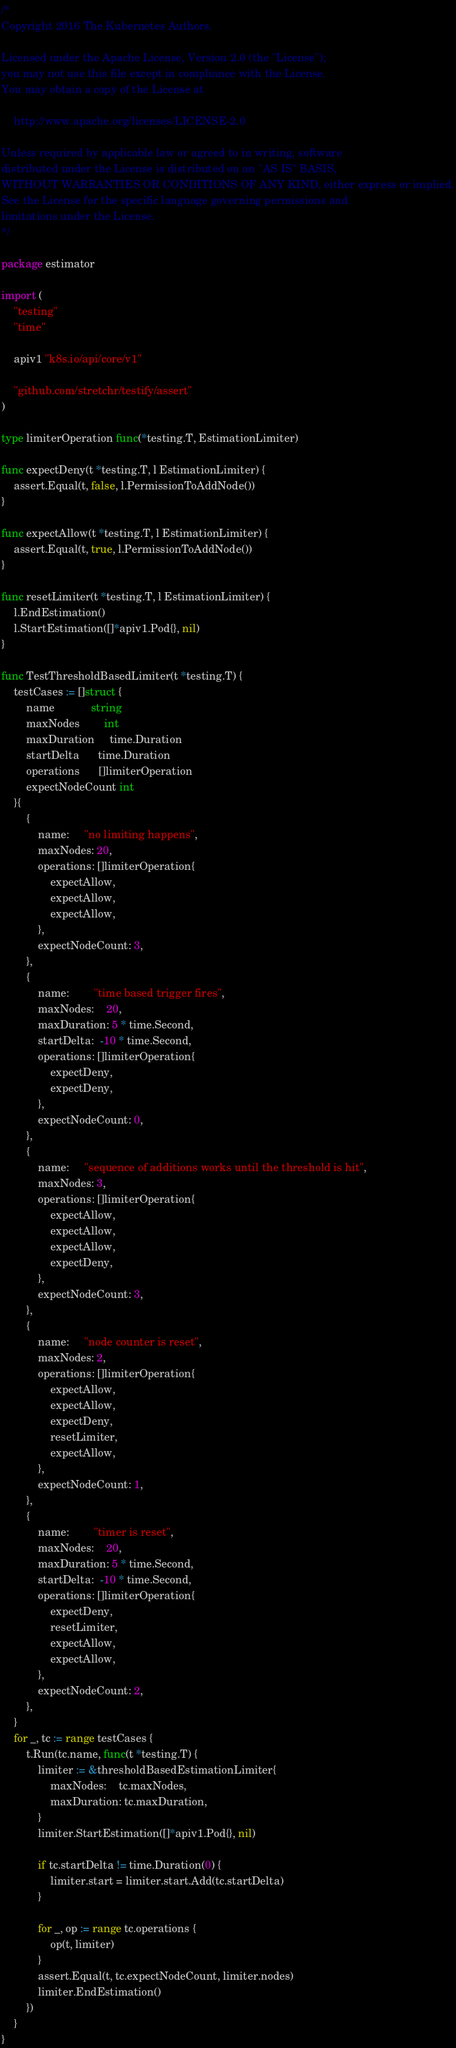<code> <loc_0><loc_0><loc_500><loc_500><_Go_>/*
Copyright 2016 The Kubernetes Authors.

Licensed under the Apache License, Version 2.0 (the "License");
you may not use this file except in compliance with the License.
You may obtain a copy of the License at

    http://www.apache.org/licenses/LICENSE-2.0

Unless required by applicable law or agreed to in writing, software
distributed under the License is distributed on an "AS IS" BASIS,
WITHOUT WARRANTIES OR CONDITIONS OF ANY KIND, either express or implied.
See the License for the specific language governing permissions and
limitations under the License.
*/

package estimator

import (
	"testing"
	"time"

	apiv1 "k8s.io/api/core/v1"

	"github.com/stretchr/testify/assert"
)

type limiterOperation func(*testing.T, EstimationLimiter)

func expectDeny(t *testing.T, l EstimationLimiter) {
	assert.Equal(t, false, l.PermissionToAddNode())
}

func expectAllow(t *testing.T, l EstimationLimiter) {
	assert.Equal(t, true, l.PermissionToAddNode())
}

func resetLimiter(t *testing.T, l EstimationLimiter) {
	l.EndEstimation()
	l.StartEstimation([]*apiv1.Pod{}, nil)
}

func TestThresholdBasedLimiter(t *testing.T) {
	testCases := []struct {
		name            string
		maxNodes        int
		maxDuration     time.Duration
		startDelta      time.Duration
		operations      []limiterOperation
		expectNodeCount int
	}{
		{
			name:     "no limiting happens",
			maxNodes: 20,
			operations: []limiterOperation{
				expectAllow,
				expectAllow,
				expectAllow,
			},
			expectNodeCount: 3,
		},
		{
			name:        "time based trigger fires",
			maxNodes:    20,
			maxDuration: 5 * time.Second,
			startDelta:  -10 * time.Second,
			operations: []limiterOperation{
				expectDeny,
				expectDeny,
			},
			expectNodeCount: 0,
		},
		{
			name:     "sequence of additions works until the threshold is hit",
			maxNodes: 3,
			operations: []limiterOperation{
				expectAllow,
				expectAllow,
				expectAllow,
				expectDeny,
			},
			expectNodeCount: 3,
		},
		{
			name:     "node counter is reset",
			maxNodes: 2,
			operations: []limiterOperation{
				expectAllow,
				expectAllow,
				expectDeny,
				resetLimiter,
				expectAllow,
			},
			expectNodeCount: 1,
		},
		{
			name:        "timer is reset",
			maxNodes:    20,
			maxDuration: 5 * time.Second,
			startDelta:  -10 * time.Second,
			operations: []limiterOperation{
				expectDeny,
				resetLimiter,
				expectAllow,
				expectAllow,
			},
			expectNodeCount: 2,
		},
	}
	for _, tc := range testCases {
		t.Run(tc.name, func(t *testing.T) {
			limiter := &thresholdBasedEstimationLimiter{
				maxNodes:    tc.maxNodes,
				maxDuration: tc.maxDuration,
			}
			limiter.StartEstimation([]*apiv1.Pod{}, nil)

			if tc.startDelta != time.Duration(0) {
				limiter.start = limiter.start.Add(tc.startDelta)
			}

			for _, op := range tc.operations {
				op(t, limiter)
			}
			assert.Equal(t, tc.expectNodeCount, limiter.nodes)
			limiter.EndEstimation()
		})
	}
}
</code> 